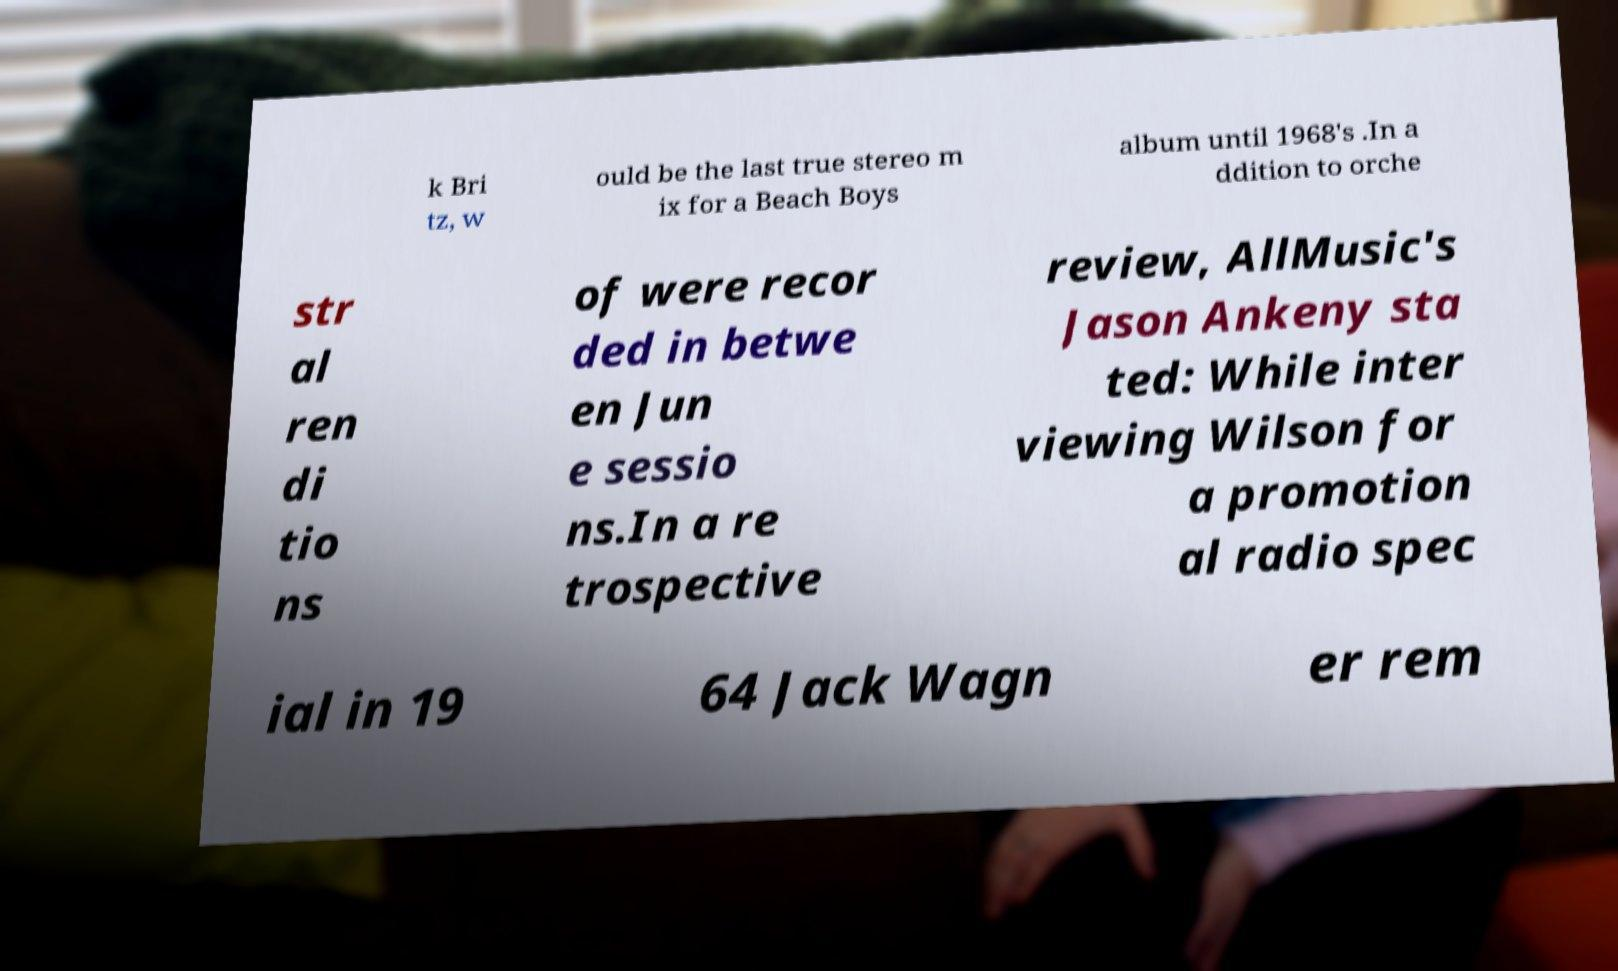Could you extract and type out the text from this image? k Bri tz, w ould be the last true stereo m ix for a Beach Boys album until 1968's .In a ddition to orche str al ren di tio ns of were recor ded in betwe en Jun e sessio ns.In a re trospective review, AllMusic's Jason Ankeny sta ted: While inter viewing Wilson for a promotion al radio spec ial in 19 64 Jack Wagn er rem 